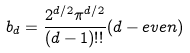Convert formula to latex. <formula><loc_0><loc_0><loc_500><loc_500>b _ { d } = \frac { 2 ^ { d / 2 } { \pi ^ { d / 2 } } } { ( d - 1 ) ! ! } ( d - e v e n )</formula> 